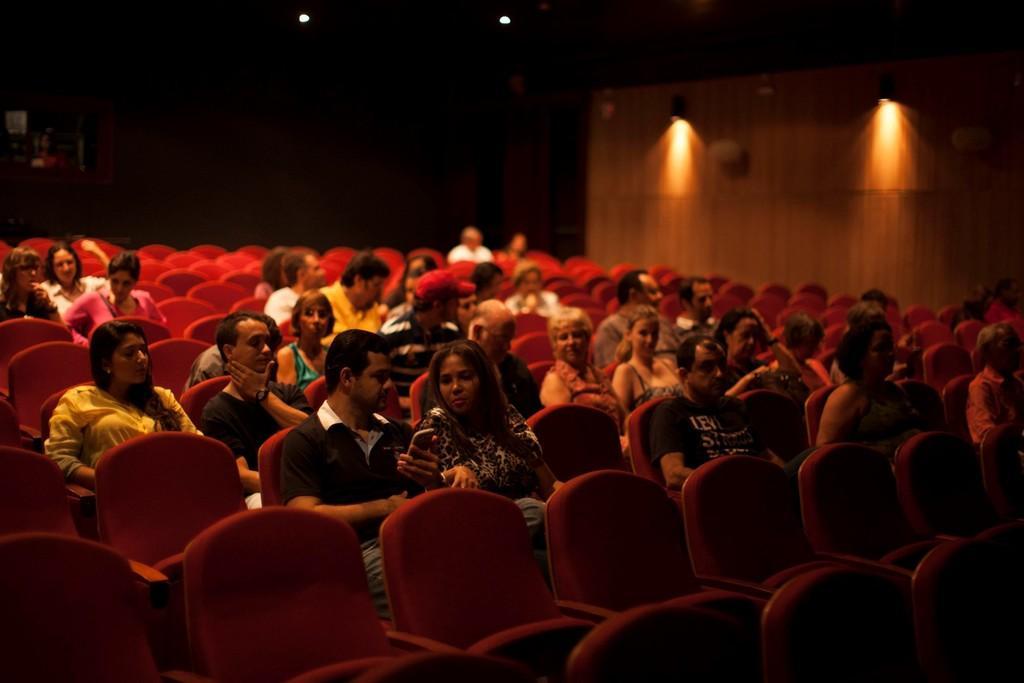How would you summarize this image in a sentence or two? This picture is taken inside a large hall. In which many red colored chairs are there. On the chairs many people are sitting. It is looking like they are watching something. This is looking like a theater. In the background there is a wall on the wall there are two lights. 